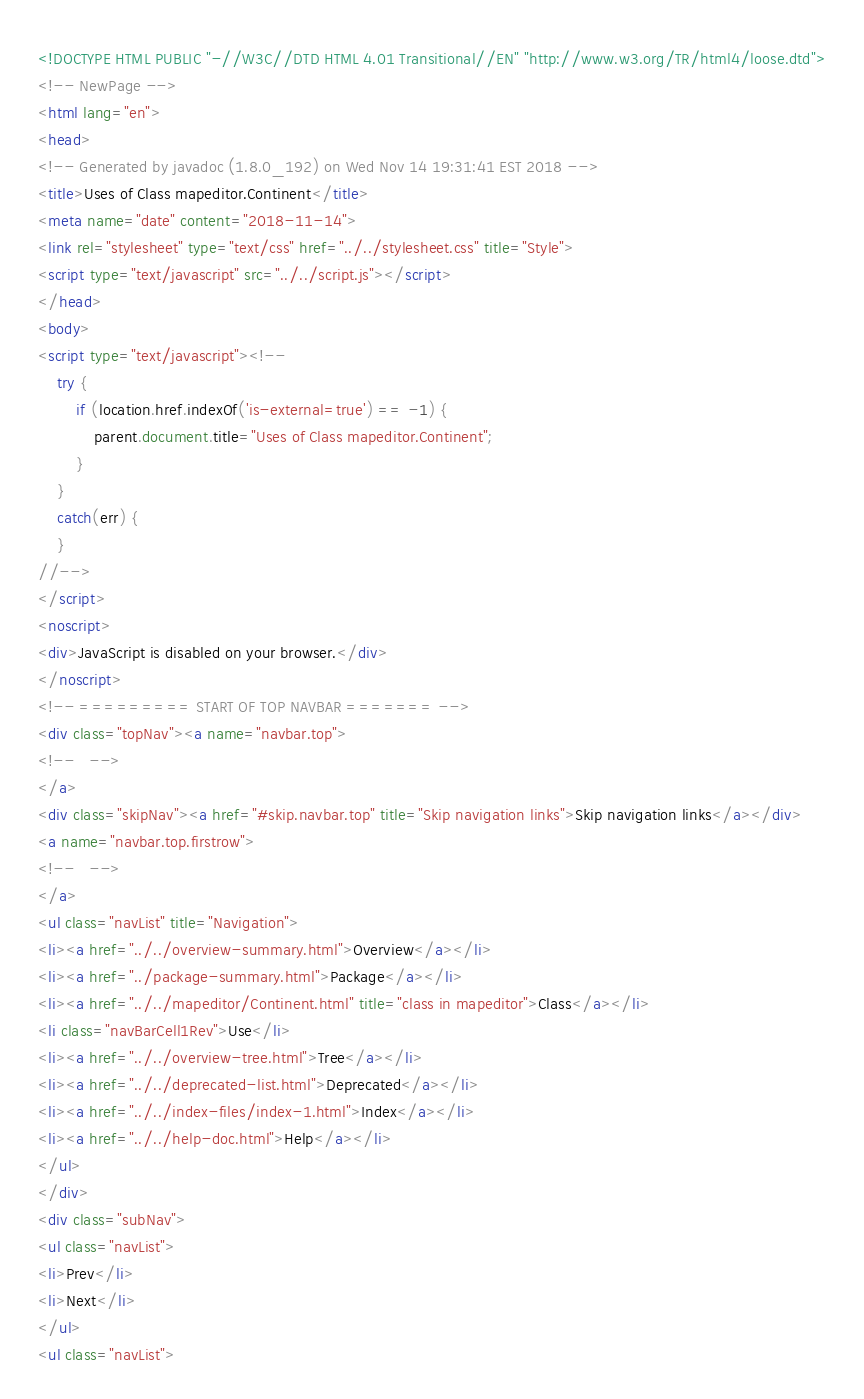<code> <loc_0><loc_0><loc_500><loc_500><_HTML_><!DOCTYPE HTML PUBLIC "-//W3C//DTD HTML 4.01 Transitional//EN" "http://www.w3.org/TR/html4/loose.dtd">
<!-- NewPage -->
<html lang="en">
<head>
<!-- Generated by javadoc (1.8.0_192) on Wed Nov 14 19:31:41 EST 2018 -->
<title>Uses of Class mapeditor.Continent</title>
<meta name="date" content="2018-11-14">
<link rel="stylesheet" type="text/css" href="../../stylesheet.css" title="Style">
<script type="text/javascript" src="../../script.js"></script>
</head>
<body>
<script type="text/javascript"><!--
    try {
        if (location.href.indexOf('is-external=true') == -1) {
            parent.document.title="Uses of Class mapeditor.Continent";
        }
    }
    catch(err) {
    }
//-->
</script>
<noscript>
<div>JavaScript is disabled on your browser.</div>
</noscript>
<!-- ========= START OF TOP NAVBAR ======= -->
<div class="topNav"><a name="navbar.top">
<!--   -->
</a>
<div class="skipNav"><a href="#skip.navbar.top" title="Skip navigation links">Skip navigation links</a></div>
<a name="navbar.top.firstrow">
<!--   -->
</a>
<ul class="navList" title="Navigation">
<li><a href="../../overview-summary.html">Overview</a></li>
<li><a href="../package-summary.html">Package</a></li>
<li><a href="../../mapeditor/Continent.html" title="class in mapeditor">Class</a></li>
<li class="navBarCell1Rev">Use</li>
<li><a href="../../overview-tree.html">Tree</a></li>
<li><a href="../../deprecated-list.html">Deprecated</a></li>
<li><a href="../../index-files/index-1.html">Index</a></li>
<li><a href="../../help-doc.html">Help</a></li>
</ul>
</div>
<div class="subNav">
<ul class="navList">
<li>Prev</li>
<li>Next</li>
</ul>
<ul class="navList"></code> 